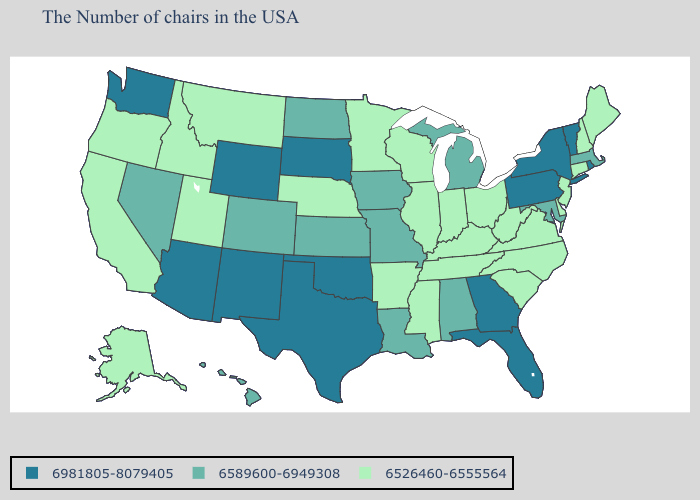Which states have the highest value in the USA?
Concise answer only. Rhode Island, Vermont, New York, Pennsylvania, Florida, Georgia, Oklahoma, Texas, South Dakota, Wyoming, New Mexico, Arizona, Washington. Name the states that have a value in the range 6589600-6949308?
Be succinct. Massachusetts, Maryland, Michigan, Alabama, Louisiana, Missouri, Iowa, Kansas, North Dakota, Colorado, Nevada, Hawaii. What is the highest value in the Northeast ?
Give a very brief answer. 6981805-8079405. How many symbols are there in the legend?
Concise answer only. 3. Does the first symbol in the legend represent the smallest category?
Quick response, please. No. What is the highest value in states that border Kentucky?
Answer briefly. 6589600-6949308. What is the lowest value in states that border Louisiana?
Be succinct. 6526460-6555564. What is the value of Washington?
Concise answer only. 6981805-8079405. Does the map have missing data?
Quick response, please. No. What is the value of New Mexico?
Answer briefly. 6981805-8079405. Among the states that border Florida , does Georgia have the highest value?
Answer briefly. Yes. Does New Mexico have the highest value in the West?
Concise answer only. Yes. Among the states that border Delaware , which have the lowest value?
Short answer required. New Jersey. What is the lowest value in states that border South Carolina?
Give a very brief answer. 6526460-6555564. What is the highest value in the USA?
Give a very brief answer. 6981805-8079405. 